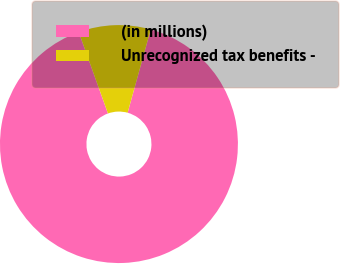Convert chart to OTSL. <chart><loc_0><loc_0><loc_500><loc_500><pie_chart><fcel>(in millions)<fcel>Unrecognized tax benefits -<nl><fcel>90.21%<fcel>9.79%<nl></chart> 